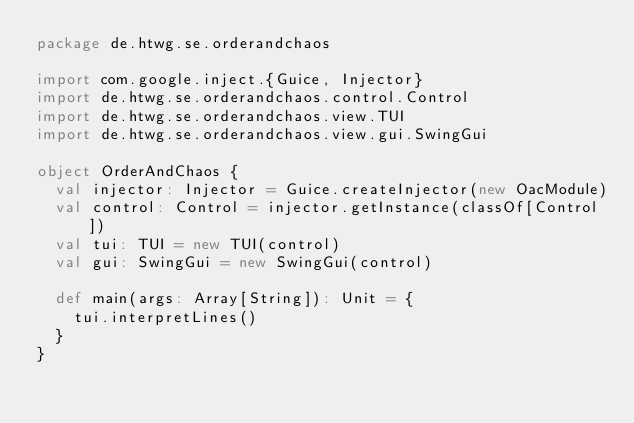Convert code to text. <code><loc_0><loc_0><loc_500><loc_500><_Scala_>package de.htwg.se.orderandchaos

import com.google.inject.{Guice, Injector}
import de.htwg.se.orderandchaos.control.Control
import de.htwg.se.orderandchaos.view.TUI
import de.htwg.se.orderandchaos.view.gui.SwingGui

object OrderAndChaos {
  val injector: Injector = Guice.createInjector(new OacModule)
  val control: Control = injector.getInstance(classOf[Control])
  val tui: TUI = new TUI(control)
  val gui: SwingGui = new SwingGui(control)

  def main(args: Array[String]): Unit = {
    tui.interpretLines()
  }
}
</code> 